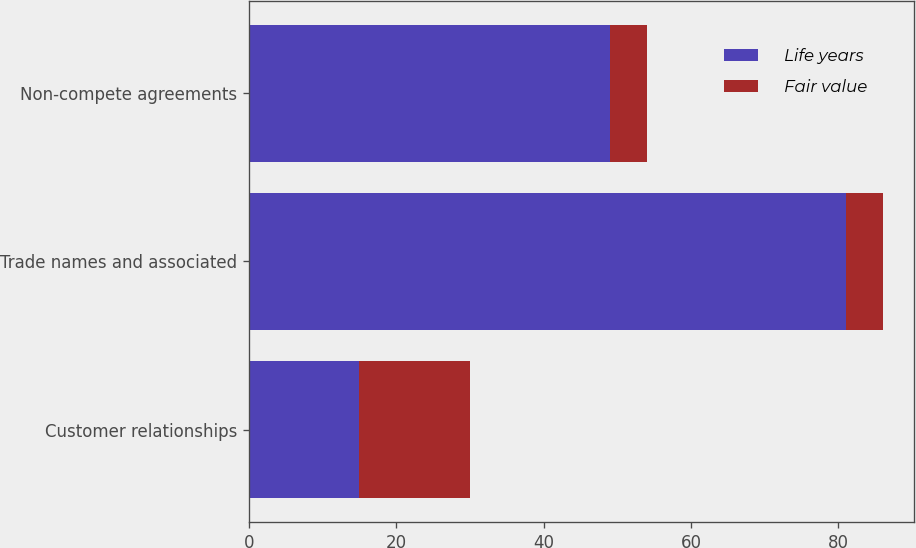<chart> <loc_0><loc_0><loc_500><loc_500><stacked_bar_chart><ecel><fcel>Customer relationships<fcel>Trade names and associated<fcel>Non-compete agreements<nl><fcel>Life years<fcel>15<fcel>81<fcel>49<nl><fcel>Fair value<fcel>15<fcel>5<fcel>5<nl></chart> 